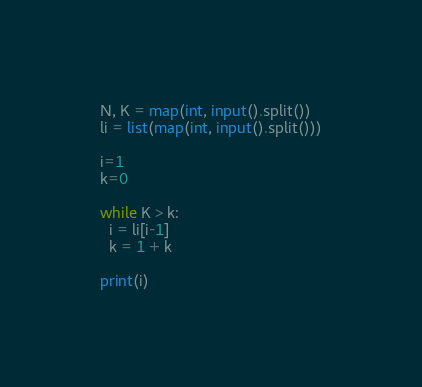Convert code to text. <code><loc_0><loc_0><loc_500><loc_500><_Python_>N, K = map(int, input().split())
li = list(map(int, input().split()))

i=1
k=0

while K > k:
  i = li[i-1]
  k = 1 + k

print(i)</code> 